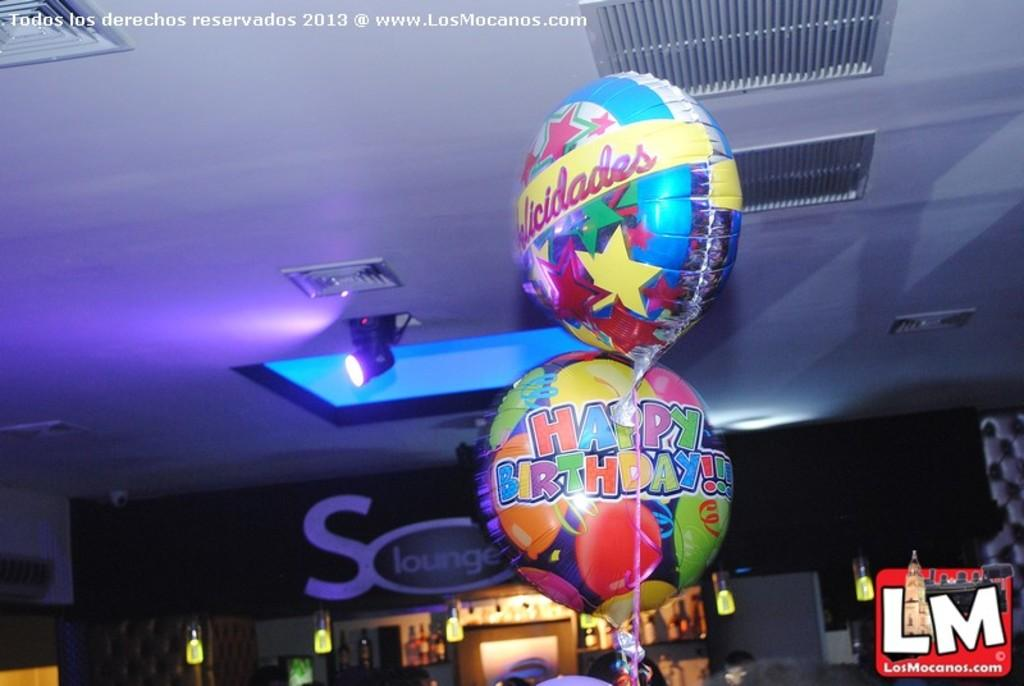<image>
Render a clear and concise summary of the photo. Two Happy birthday balloons on top of one another. 